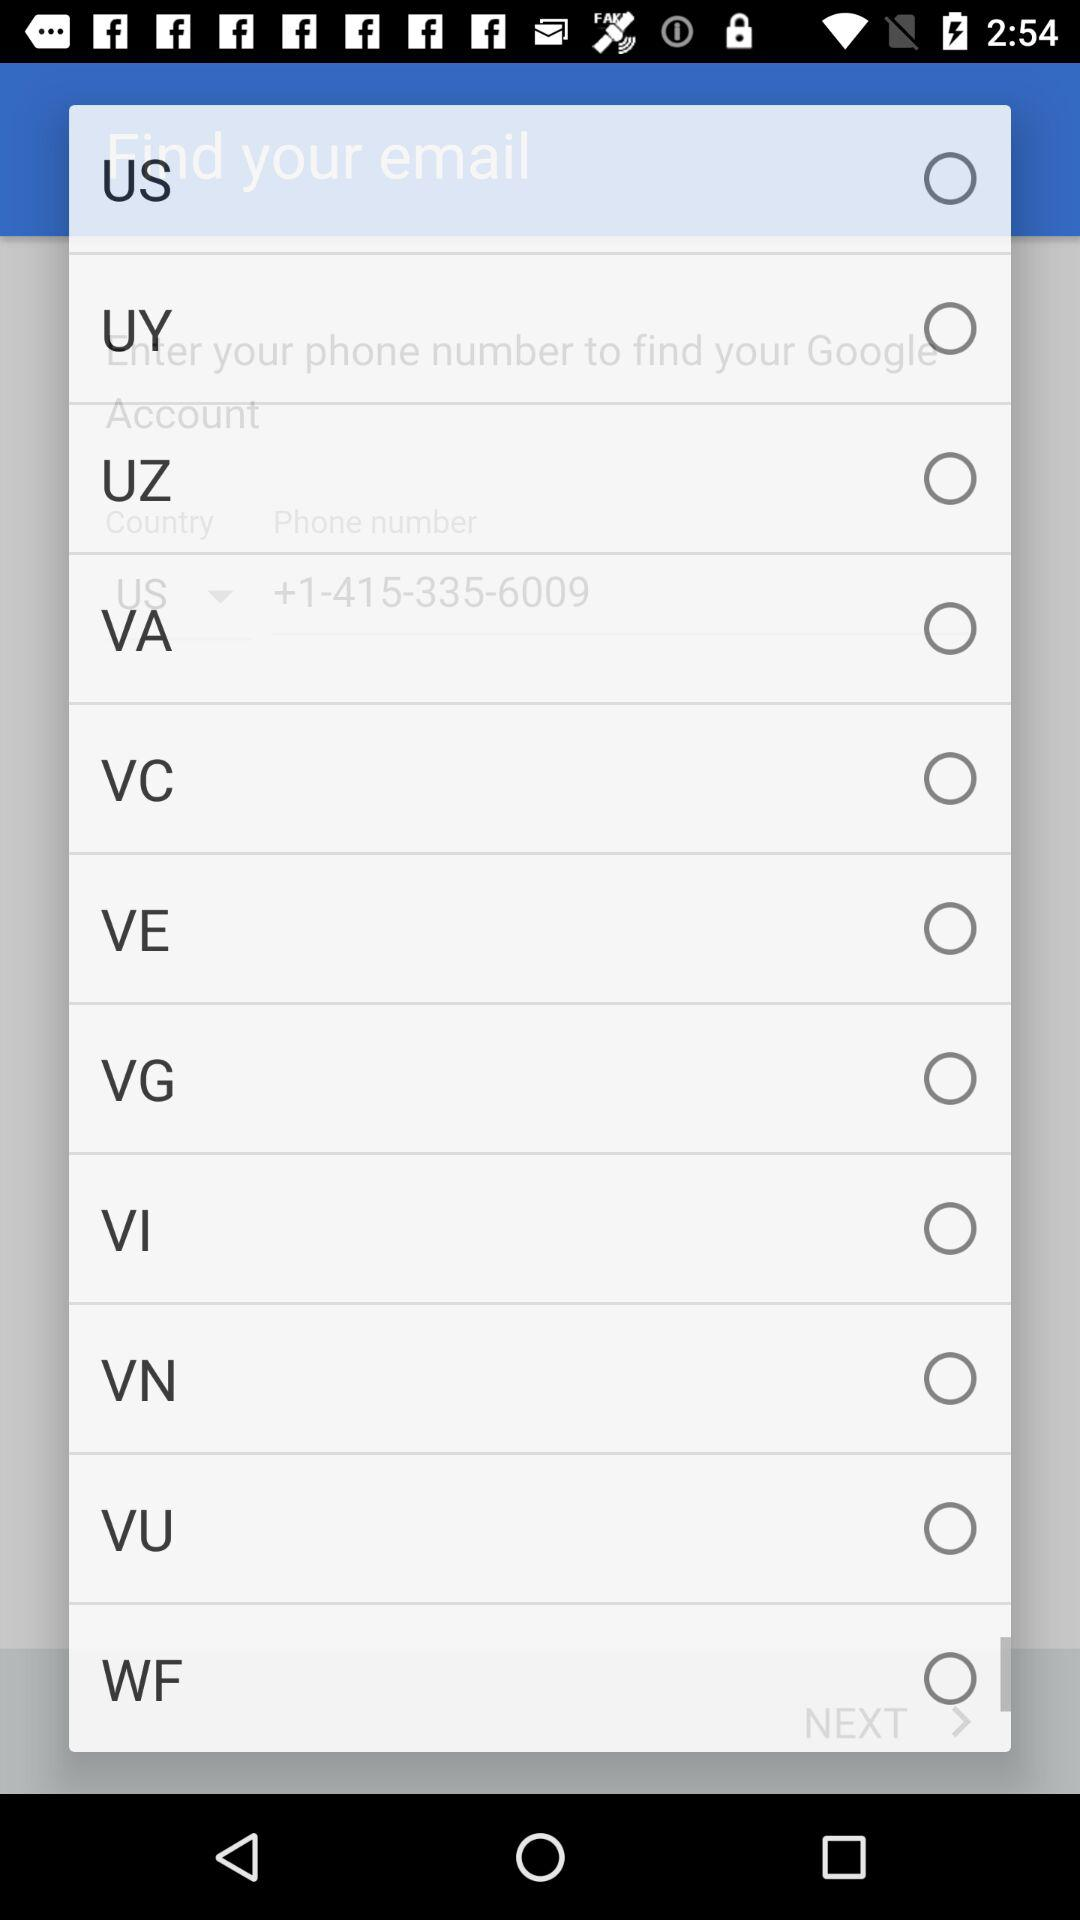Is the "VA" radio button selected or not? The "VA" radio button is not selected. 